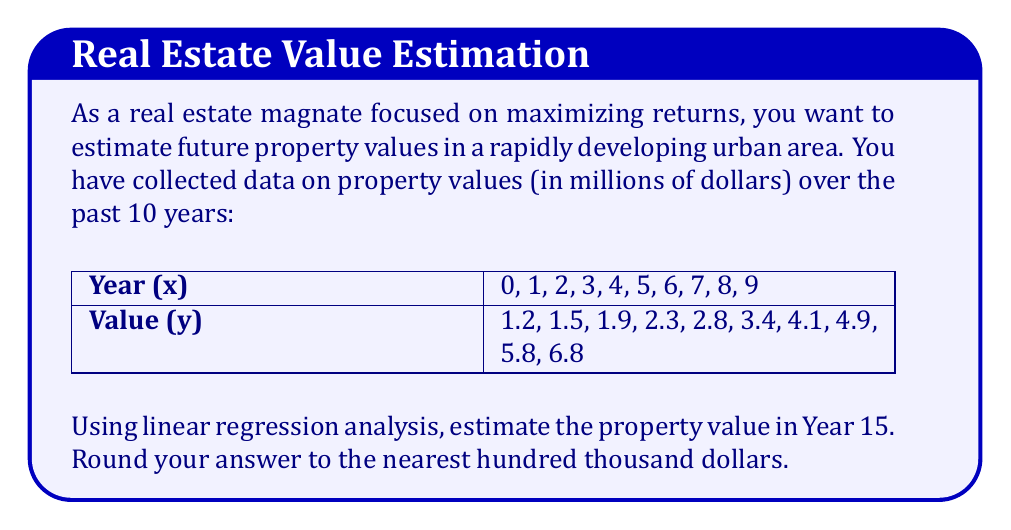Show me your answer to this math problem. To estimate the future property value using linear regression, we need to follow these steps:

1. Calculate the means of x and y:
   $\bar{x} = \frac{\sum x}{n} = \frac{45}{10} = 4.5$
   $\bar{y} = \frac{\sum y}{n} = \frac{34.7}{10} = 3.47$

2. Calculate the slope (m) of the regression line:
   $m = \frac{\sum (x - \bar{x})(y - \bar{y})}{\sum (x - \bar{x})^2}$

   To do this, we create a table:
   
   | x | y | $(x - \bar{x})$ | $(y - \bar{y})$ | $(x - \bar{x})(y - \bar{y})$ | $(x - \bar{x})^2$ |
   |---|---|-----------------|-----------------|--------------------------------|-------------------|
   | 0 | 1.2 | -4.5 | -2.27 | 10.215 | 20.25 |
   | 1 | 1.5 | -3.5 | -1.97 | 6.895 | 12.25 |
   | 2 | 1.9 | -2.5 | -1.57 | 3.925 | 6.25 |
   | 3 | 2.3 | -1.5 | -1.17 | 1.755 | 2.25 |
   | 4 | 2.8 | -0.5 | -0.67 | 0.335 | 0.25 |
   | 5 | 3.4 | 0.5 | -0.07 | -0.035 | 0.25 |
   | 6 | 4.1 | 1.5 | 0.63 | 0.945 | 2.25 |
   | 7 | 4.9 | 2.5 | 1.43 | 3.575 | 6.25 |
   | 8 | 5.8 | 3.5 | 2.33 | 8.155 | 12.25 |
   | 9 | 6.8 | 4.5 | 3.33 | 14.985 | 20.25 |

   Sum of $(x - \bar{x})(y - \bar{y}) = 50.75$
   Sum of $(x - \bar{x})^2 = 82.5$

   $m = \frac{50.75}{82.5} = 0.615$

3. Calculate the y-intercept (b) of the regression line:
   $b = \bar{y} - m\bar{x} = 3.47 - (0.615 \times 4.5) = 0.7025$

4. The regression line equation is:
   $y = mx + b = 0.615x + 0.7025$

5. To estimate the property value in Year 15, substitute x = 15:
   $y = 0.615(15) + 0.7025 = 9.9275$

Therefore, the estimated property value in Year 15 is $9.9275 million.
Answer: $9.9 million 